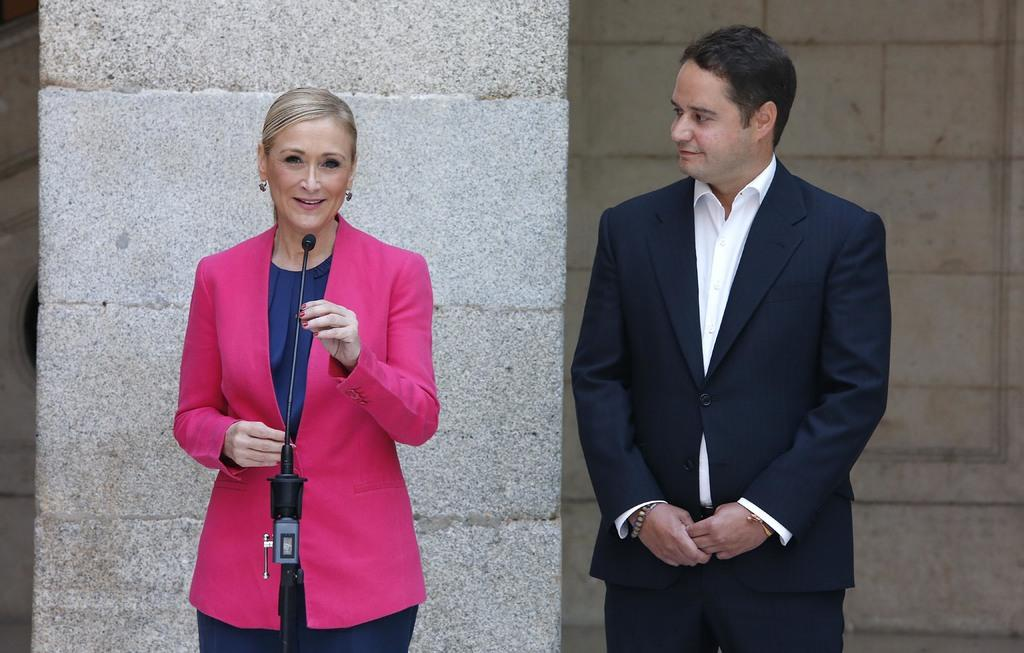What is the woman on the left side of the image doing? The woman is standing on the left side of the image and holding a mic. Who else is present in the image? There is a man on the right side of the image. What can be seen in the background of the image? There is a pillar and a wall in the background of the image. What type of waves can be seen crashing against the shore in the image? There are no waves or shoreline present in the image; it features a woman holding a mic and a man on the right side, with a pillar and a wall in the background. 